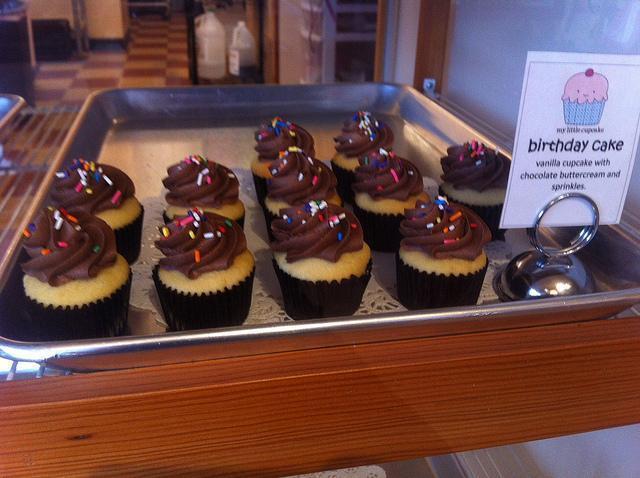How many cupcakes are on the table?
Give a very brief answer. 11. How many cakes are in the photo?
Give a very brief answer. 11. How many people are riding the elephant?
Give a very brief answer. 0. 